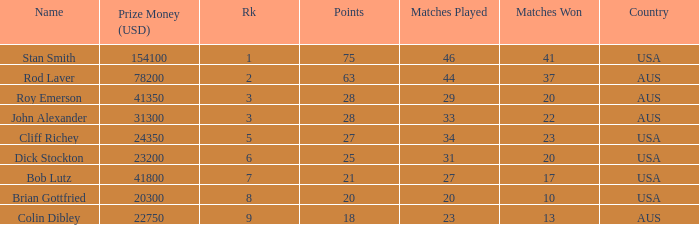How many countries had 21 points 1.0. 